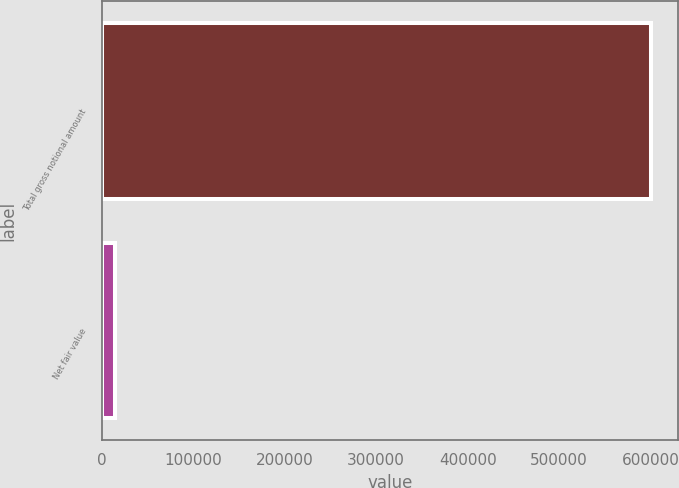Convert chart. <chart><loc_0><loc_0><loc_500><loc_500><bar_chart><fcel>Total gross notional amount<fcel>Net fair value<nl><fcel>599844<fcel>14695<nl></chart> 